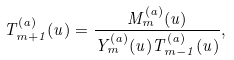<formula> <loc_0><loc_0><loc_500><loc_500>T _ { m + 1 } ^ { ( a ) } ( u ) = \frac { M _ { m } ^ { ( a ) } ( u ) } { Y _ { m } ^ { ( a ) } ( u ) T _ { m - 1 } ^ { ( a ) } ( u ) } ,</formula> 